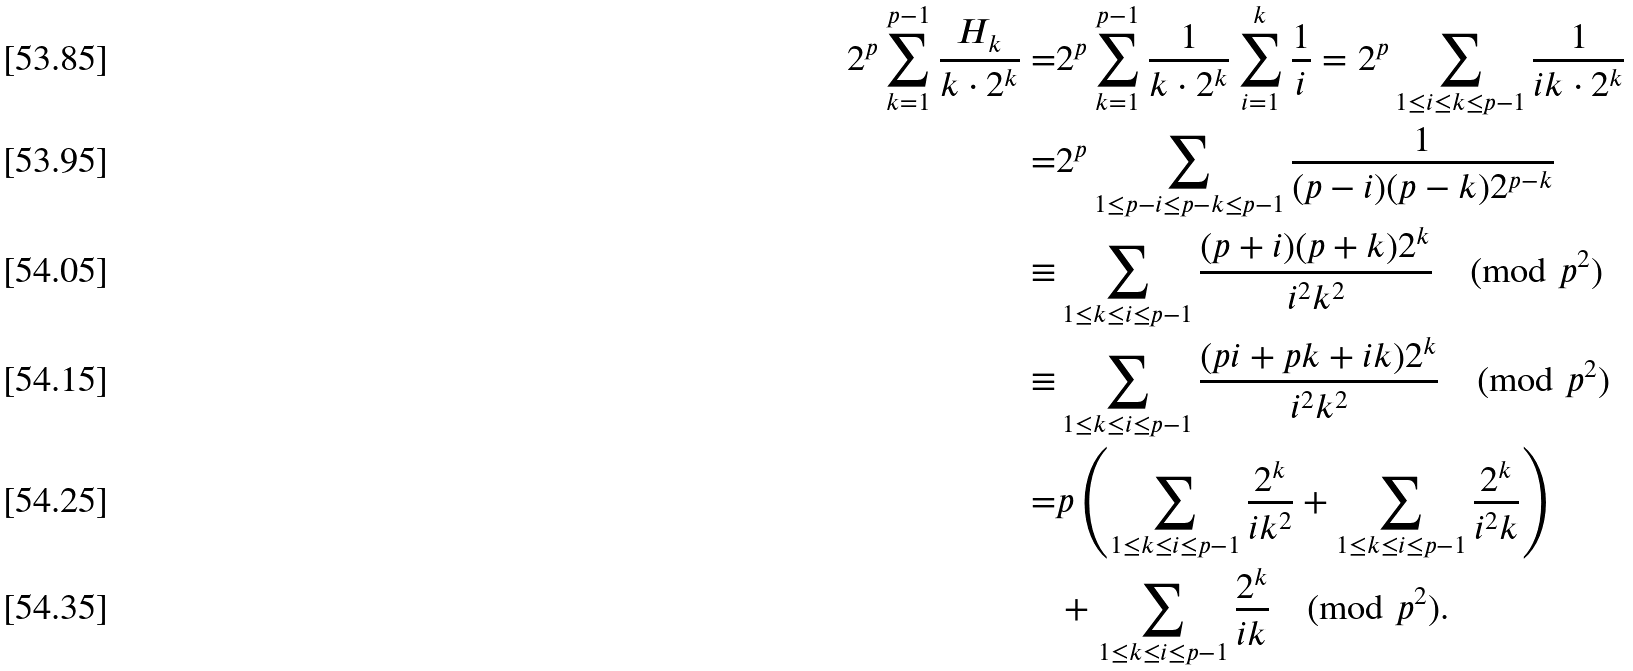<formula> <loc_0><loc_0><loc_500><loc_500>2 ^ { p } \sum _ { k = 1 } ^ { p - 1 } \frac { H _ { k } } { k \cdot 2 ^ { k } } = & 2 ^ { p } \sum _ { k = 1 } ^ { p - 1 } \frac { 1 } { k \cdot 2 ^ { k } } \sum _ { i = 1 } ^ { k } \frac { 1 } { i } = 2 ^ { p } \sum _ { 1 \leq i \leq k \leq p - 1 } \frac { 1 } { i k \cdot 2 ^ { k } } \\ = & 2 ^ { p } \sum _ { 1 \leq p - i \leq p - k \leq p - 1 } \frac { 1 } { ( p - i ) ( p - k ) 2 ^ { p - k } } \\ \equiv & \sum _ { 1 \leq k \leq i \leq p - 1 } \frac { ( p + i ) ( p + k ) 2 ^ { k } } { i ^ { 2 } k ^ { 2 } } \pmod { p ^ { 2 } } \\ \equiv & \sum _ { 1 \leq k \leq i \leq p - 1 } \frac { ( p i + p k + i k ) 2 ^ { k } } { i ^ { 2 } k ^ { 2 } } \pmod { p ^ { 2 } } \\ = & p \left ( \sum _ { 1 \leq k \leq i \leq p - 1 } \frac { 2 ^ { k } } { i k ^ { 2 } } + \sum _ { 1 \leq k \leq i \leq p - 1 } \frac { 2 ^ { k } } { i ^ { 2 } k } \right ) \\ & + \sum _ { 1 \leq k \leq i \leq p - 1 } \frac { 2 ^ { k } } { i k } \pmod { p ^ { 2 } } .</formula> 